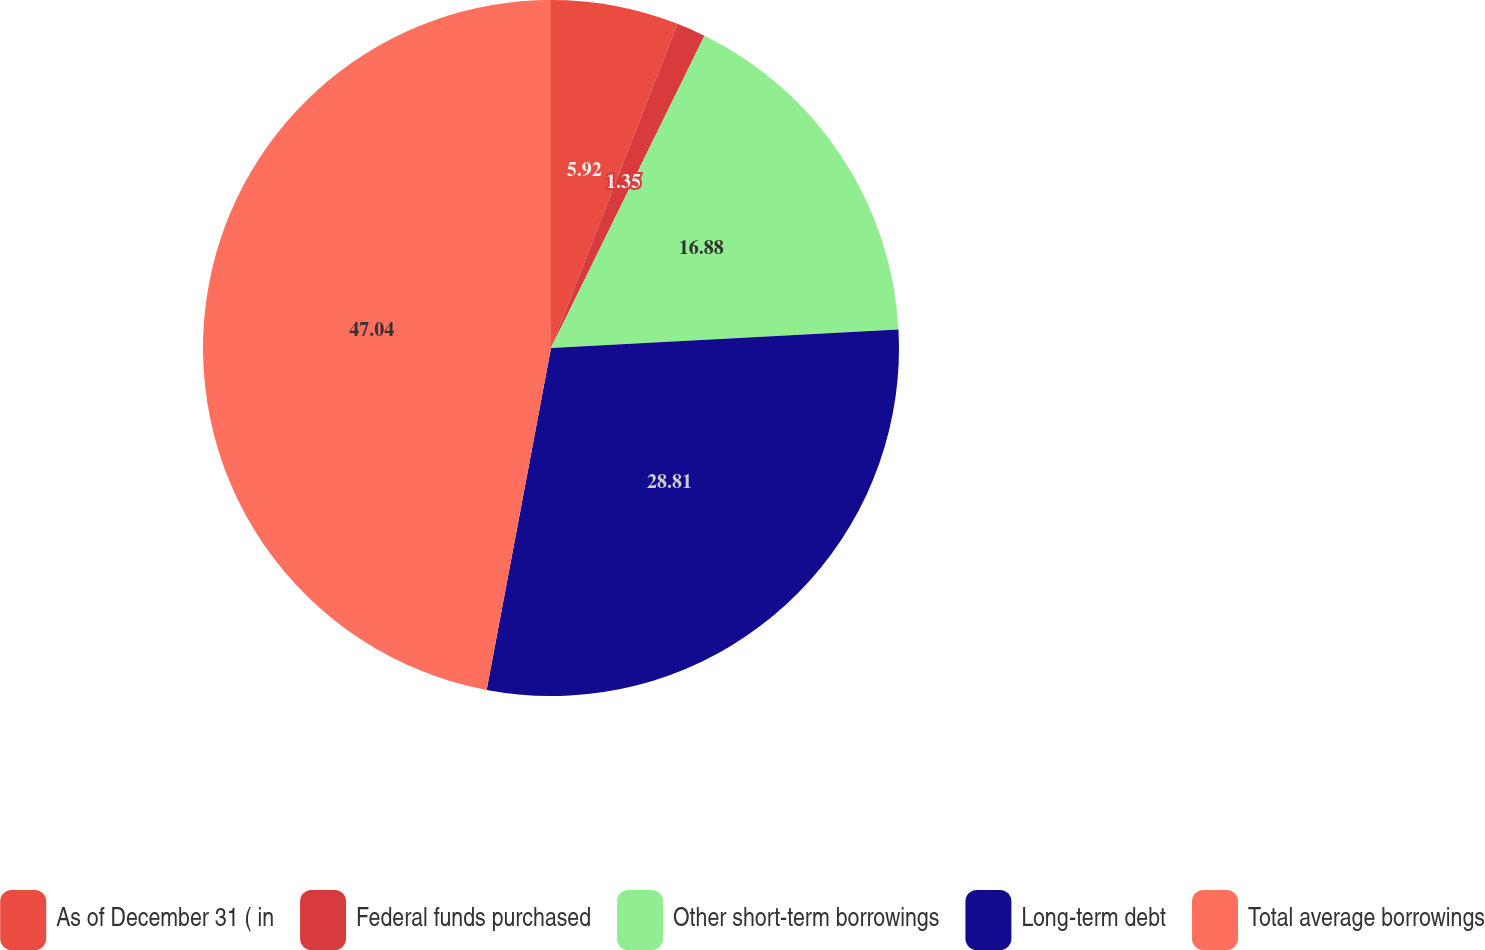Convert chart to OTSL. <chart><loc_0><loc_0><loc_500><loc_500><pie_chart><fcel>As of December 31 ( in<fcel>Federal funds purchased<fcel>Other short-term borrowings<fcel>Long-term debt<fcel>Total average borrowings<nl><fcel>5.92%<fcel>1.35%<fcel>16.88%<fcel>28.81%<fcel>47.04%<nl></chart> 